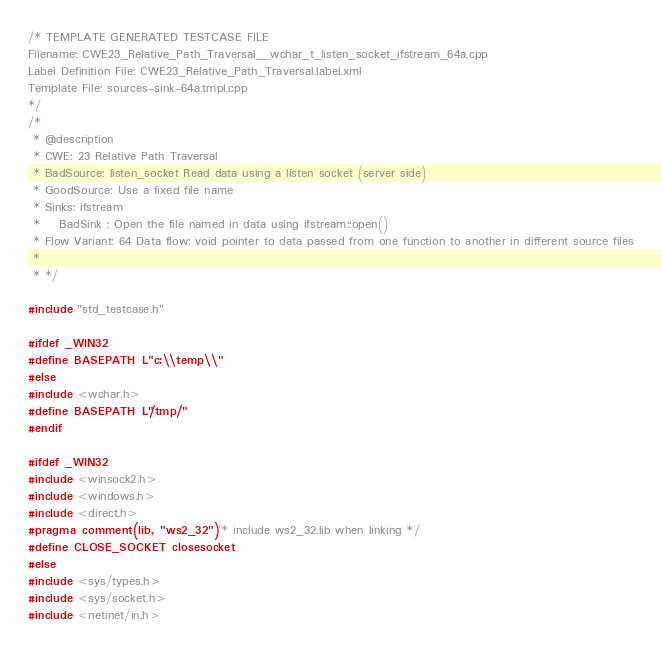Convert code to text. <code><loc_0><loc_0><loc_500><loc_500><_C++_>/* TEMPLATE GENERATED TESTCASE FILE
Filename: CWE23_Relative_Path_Traversal__wchar_t_listen_socket_ifstream_64a.cpp
Label Definition File: CWE23_Relative_Path_Traversal.label.xml
Template File: sources-sink-64a.tmpl.cpp
*/
/*
 * @description
 * CWE: 23 Relative Path Traversal
 * BadSource: listen_socket Read data using a listen socket (server side)
 * GoodSource: Use a fixed file name
 * Sinks: ifstream
 *    BadSink : Open the file named in data using ifstream::open()
 * Flow Variant: 64 Data flow: void pointer to data passed from one function to another in different source files
 *
 * */

#include "std_testcase.h"

#ifdef _WIN32
#define BASEPATH L"c:\\temp\\"
#else
#include <wchar.h>
#define BASEPATH L"/tmp/"
#endif

#ifdef _WIN32
#include <winsock2.h>
#include <windows.h>
#include <direct.h>
#pragma comment(lib, "ws2_32") /* include ws2_32.lib when linking */
#define CLOSE_SOCKET closesocket
#else
#include <sys/types.h>
#include <sys/socket.h>
#include <netinet/in.h></code> 